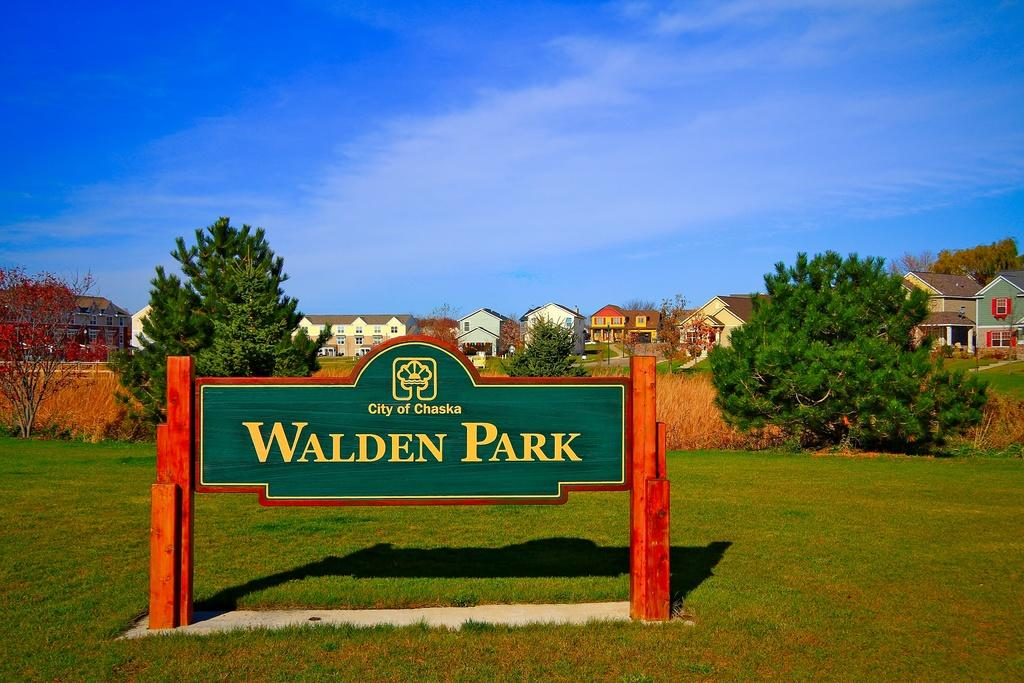What is the main object in the image? There is a name board in the image. How is the name board supported? The name board is on poles. Where is the name board located? The name board is on a grassy area. What can be seen in the background of the image? In the background of the image, there are trees and buildings, and clouds are present in the sky. How many eggs are visible on the name board in the image? There are no eggs visible on the name board in the image. 